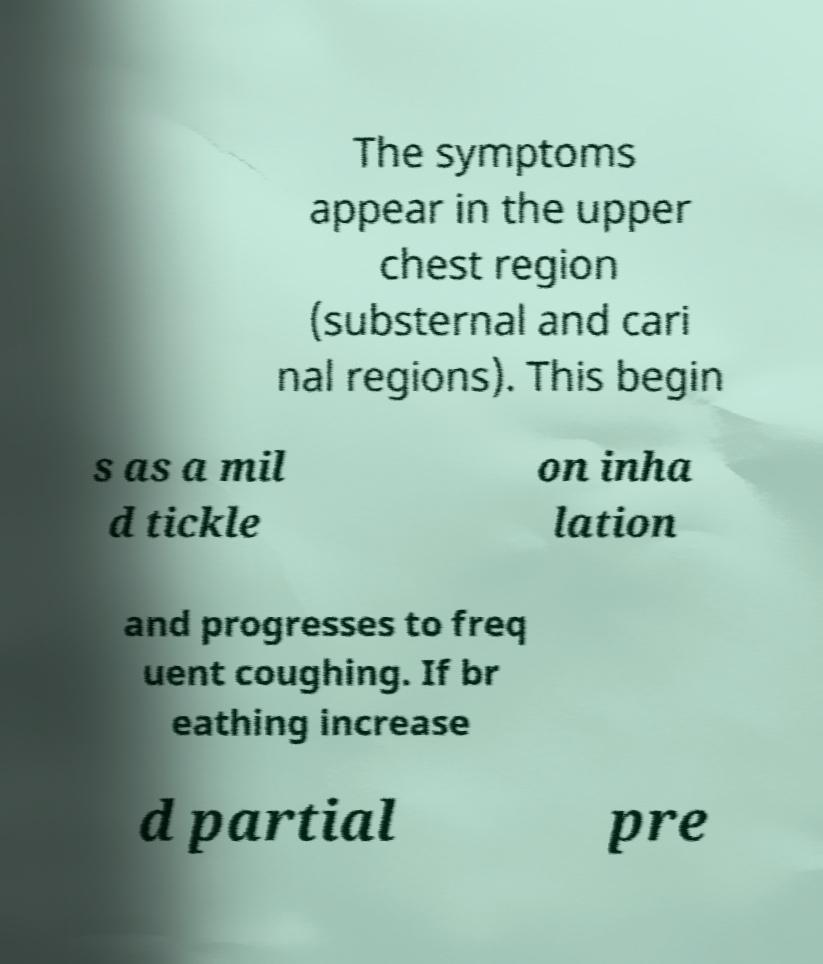Please read and relay the text visible in this image. What does it say? The symptoms appear in the upper chest region (substernal and cari nal regions). This begin s as a mil d tickle on inha lation and progresses to freq uent coughing. If br eathing increase d partial pre 